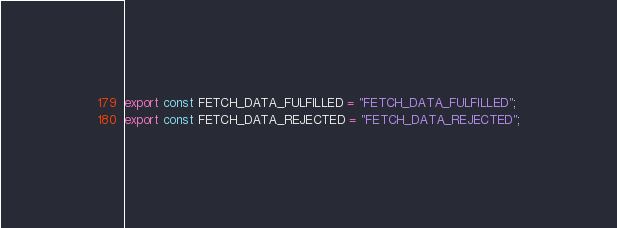Convert code to text. <code><loc_0><loc_0><loc_500><loc_500><_JavaScript_>export const FETCH_DATA_FULFILLED = "FETCH_DATA_FULFILLED";
export const FETCH_DATA_REJECTED = "FETCH_DATA_REJECTED";</code> 